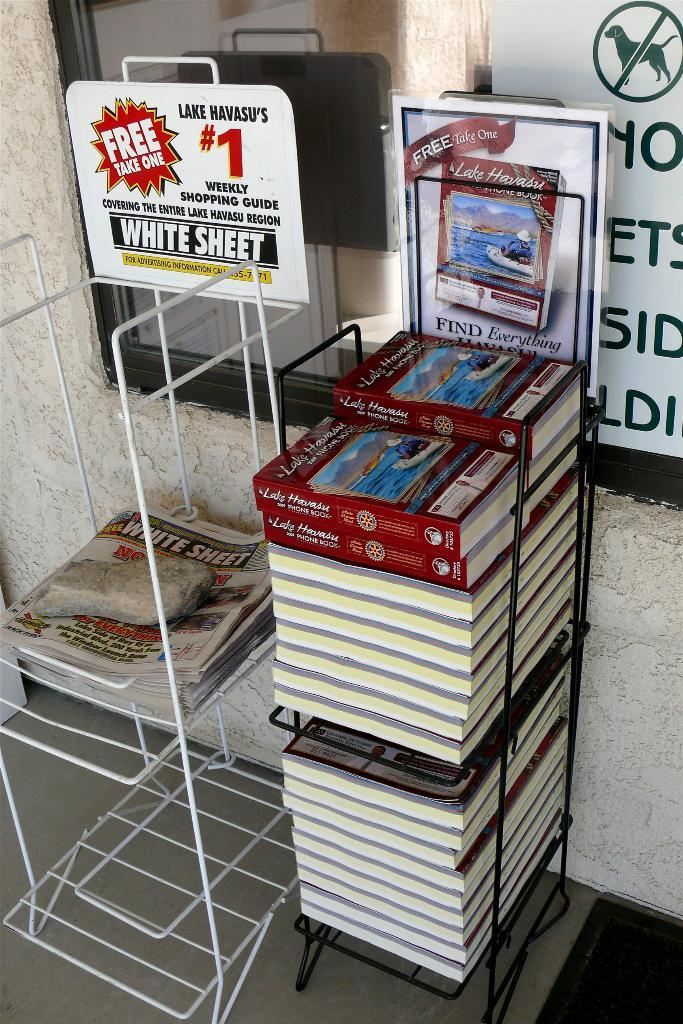<image>
Give a short and clear explanation of the subsequent image. a stack of books that say lake havasu on the cover of them 